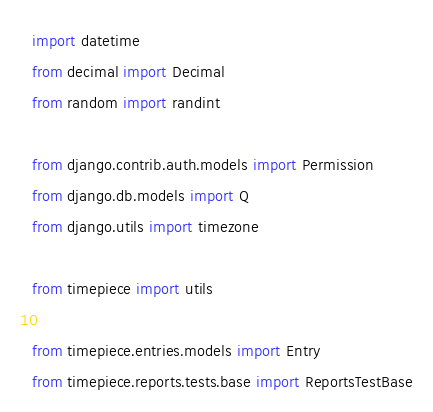<code> <loc_0><loc_0><loc_500><loc_500><_Python_>import datetime
from decimal import Decimal
from random import randint

from django.contrib.auth.models import Permission
from django.db.models import Q
from django.utils import timezone

from timepiece import utils

from timepiece.entries.models import Entry
from timepiece.reports.tests.base import ReportsTestBase</code> 